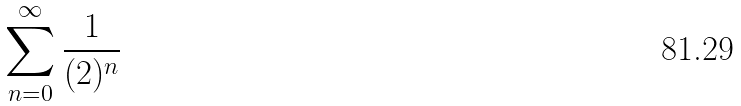<formula> <loc_0><loc_0><loc_500><loc_500>\sum _ { n = 0 } ^ { \infty } \frac { 1 } { ( 2 ) ^ { n } }</formula> 